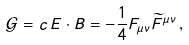Convert formula to latex. <formula><loc_0><loc_0><loc_500><loc_500>\mathcal { G } = c \, E \cdot B = - \frac { 1 } { 4 } F _ { \mu \nu } \widetilde { F } ^ { \mu \nu } \, ,</formula> 